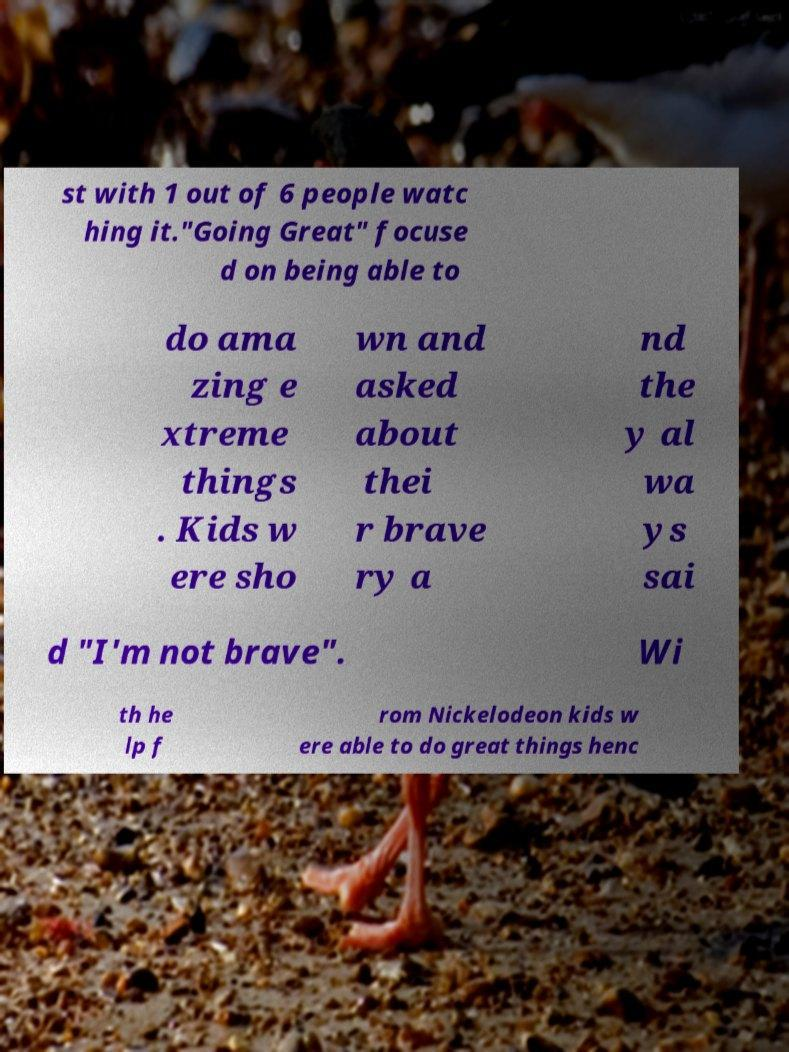Please identify and transcribe the text found in this image. st with 1 out of 6 people watc hing it."Going Great" focuse d on being able to do ama zing e xtreme things . Kids w ere sho wn and asked about thei r brave ry a nd the y al wa ys sai d "I'm not brave". Wi th he lp f rom Nickelodeon kids w ere able to do great things henc 